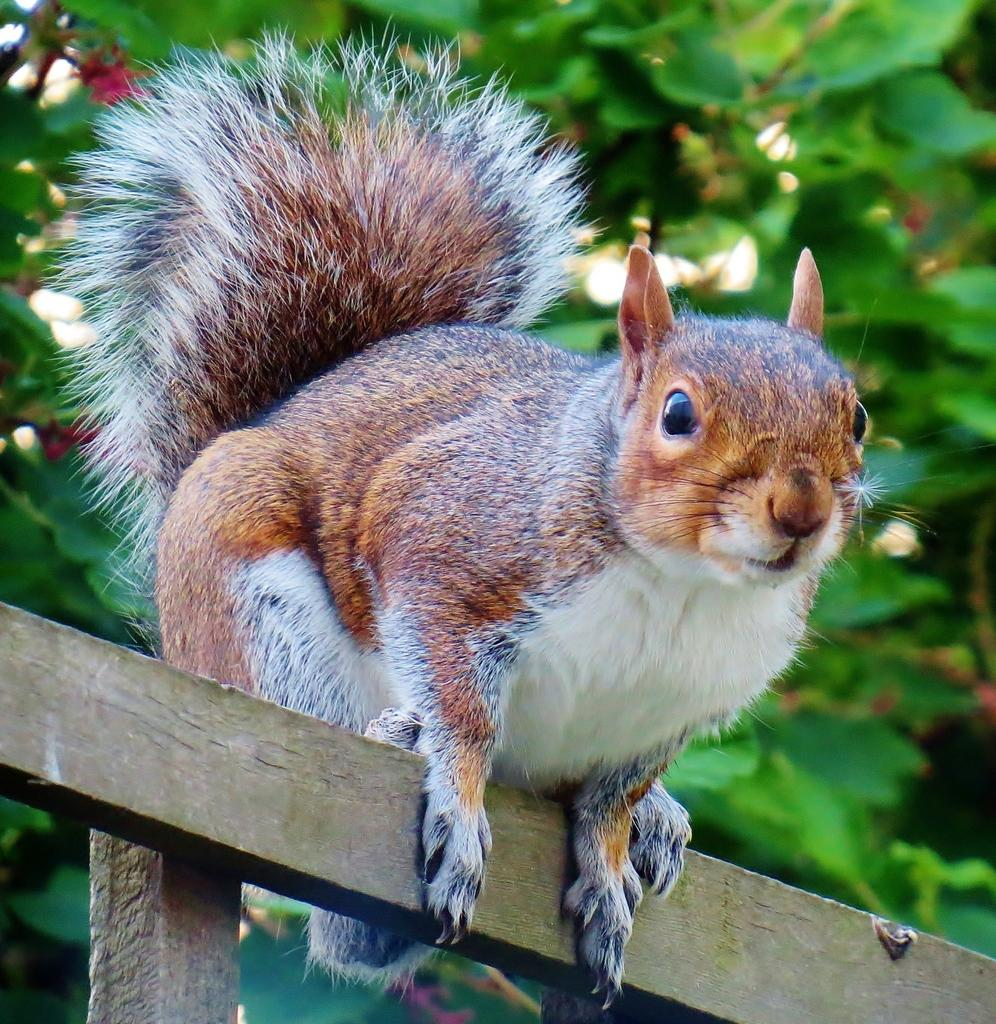What animal is present in the image? There is a squirrel in the image. What is the squirrel standing on? The squirrel is standing on a wooden stick. What can be seen in the background of the image? In the background, there are trees with leaves. How many jellyfish can be seen swimming in the background of the image? There are no jellyfish present in the image; it features a squirrel standing on a wooden stick with trees in the background. 